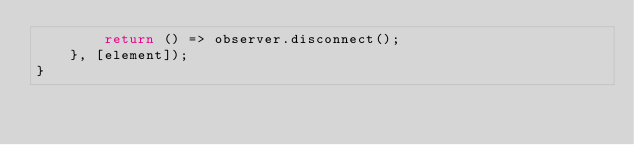<code> <loc_0><loc_0><loc_500><loc_500><_TypeScript_>        return () => observer.disconnect();
    }, [element]);
}
</code> 